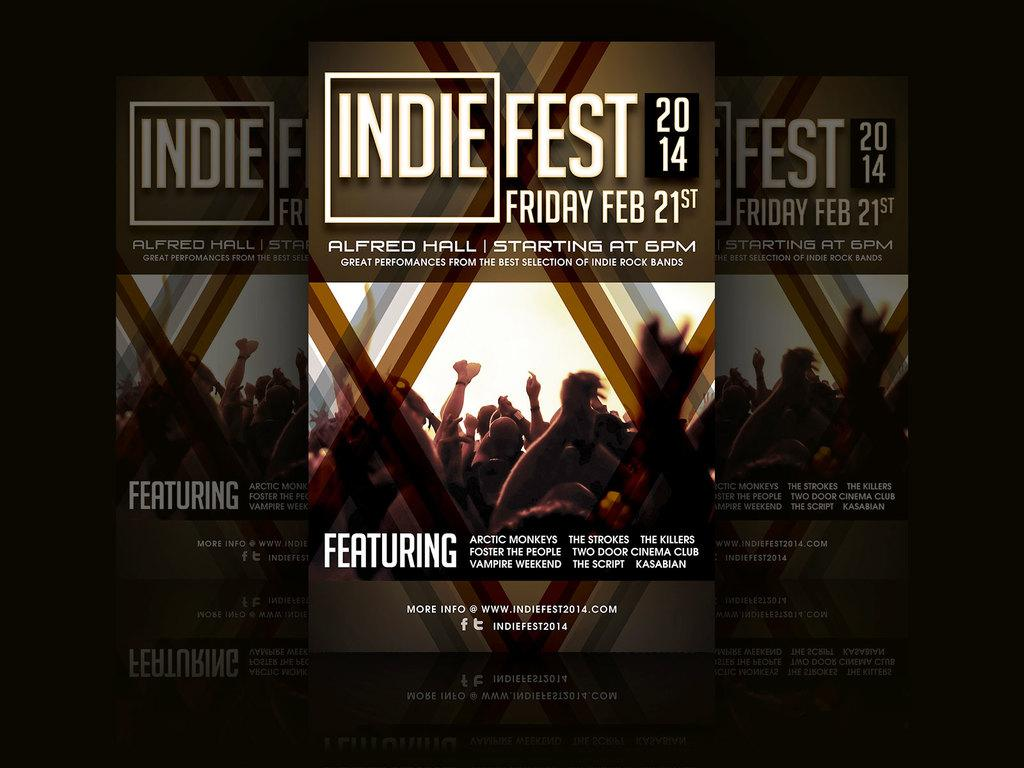<image>
Write a terse but informative summary of the picture. A flyer for Indie Fest 2014 set to take place on Friday Feb 21st Featuring bands like Arctic Monkeys and Vampire Weekend. 